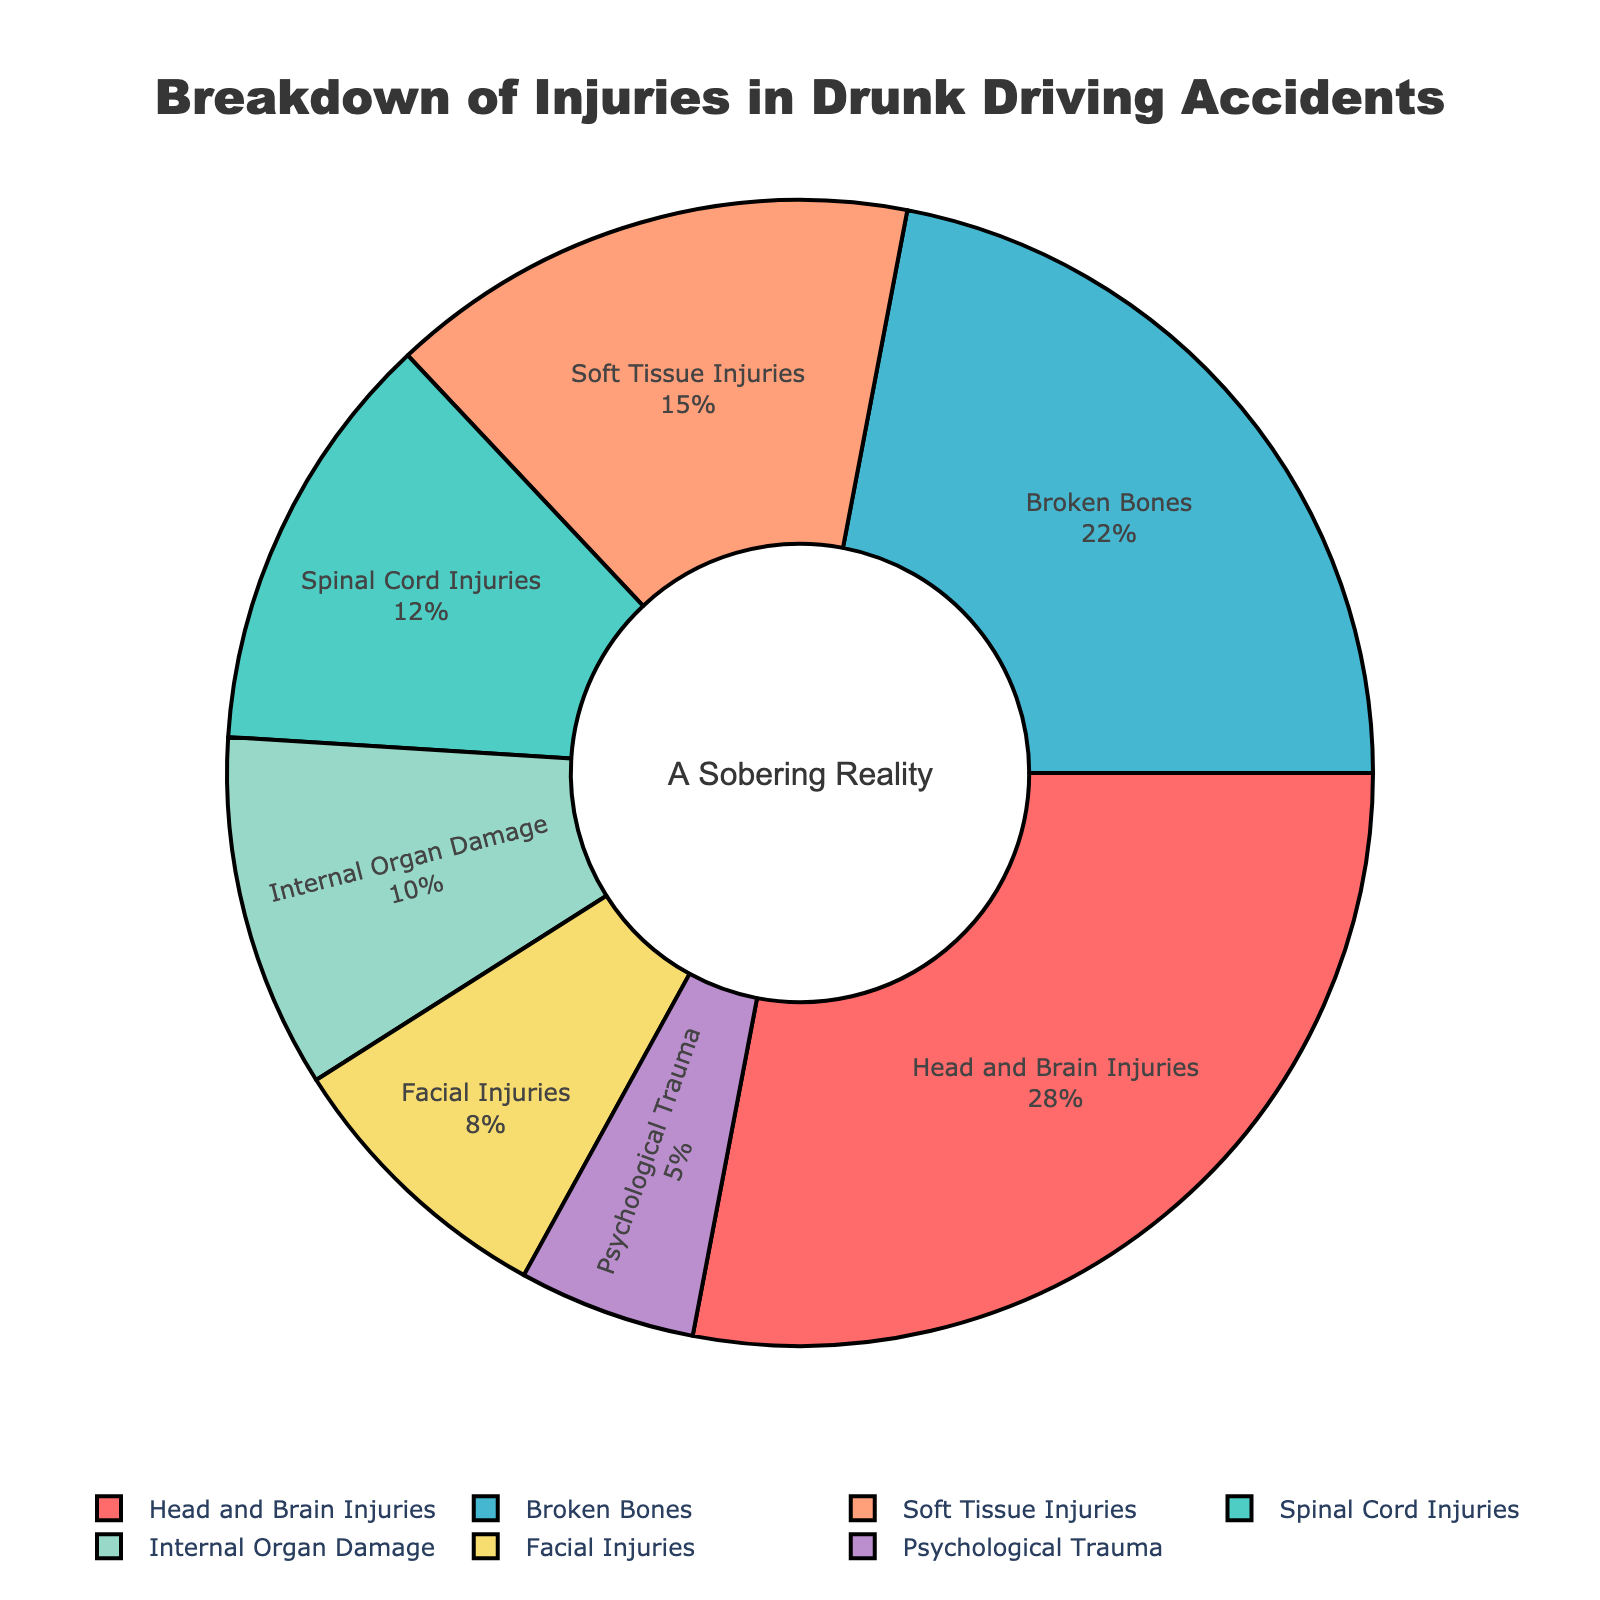what type of injury is the most common in drunk driving accidents? The largest segment in the pie chart represents the most common type of injury. According to the chart, "Head and Brain Injuries" takes up the most significant portion, which means it's the most common.
Answer: Head and Brain Injuries What's the combined percentage of Soft Tissue Injuries and Internal Organ Damage? According to the pie chart, Soft Tissue Injuries account for 15% and Internal Organ Damage accounts for 10%. Adding these percentages together, we get 15% + 10% = 25%.
Answer: 25% Are Spinal Cord Injuries more or less common than Facial Injuries? Comparing the sizes of the segments in the pie chart, we see that Spinal Cord Injuries take up 12%, whereas Facial Injuries account for 8%. Since 12% is more than 8%, Spinal Cord Injuries are more common.
Answer: More common What percentage of injuries are not related to either Broken Bones or Head and Brain Injuries? First, we sum up the percentages for Broken Bones and Head and Brain Injuries: 22% + 28% = 50%. Since the total percentage in a pie chart is 100%, the percentage not related to these injuries is 100% - 50% = 50%.
Answer: 50% Which type of injury is represented by the green segment? By referring to the colors in the pie chart, the green segment represents "Spinal Cord Injuries," which account for 12% of the total.
Answer: Spinal Cord Injuries What is the ratio of Psychological Trauma to Head and Brain Injuries? According to the chart, Psychological Trauma makes up 5%, and Head and Brain Injuries make up 28%. The ratio of Psychological Trauma to Head and Brain Injuries is 5:28.
Answer: 5:28 Is the percentage of Internal Organ Damage greater than the combined percentage of Facial Injuries and Psychological Trauma? Internal Organ Damage accounts for 10%. Facial Injuries and Psychological Trauma add up to 8% + 5% = 13%. Since 10% is less than 13%, Internal Organ Damage is not greater.
Answer: No What injuries constitute nearly half of all injuries in drunk driving accidents? Broken Bones account for 22%, and Head and Brain Injuries account for 28%. Adding these gives us 22% + 28% = 50%, which constitutes half the injuries in drunk driving accidents.
Answer: Broken Bones and Head and Brain Injuries 